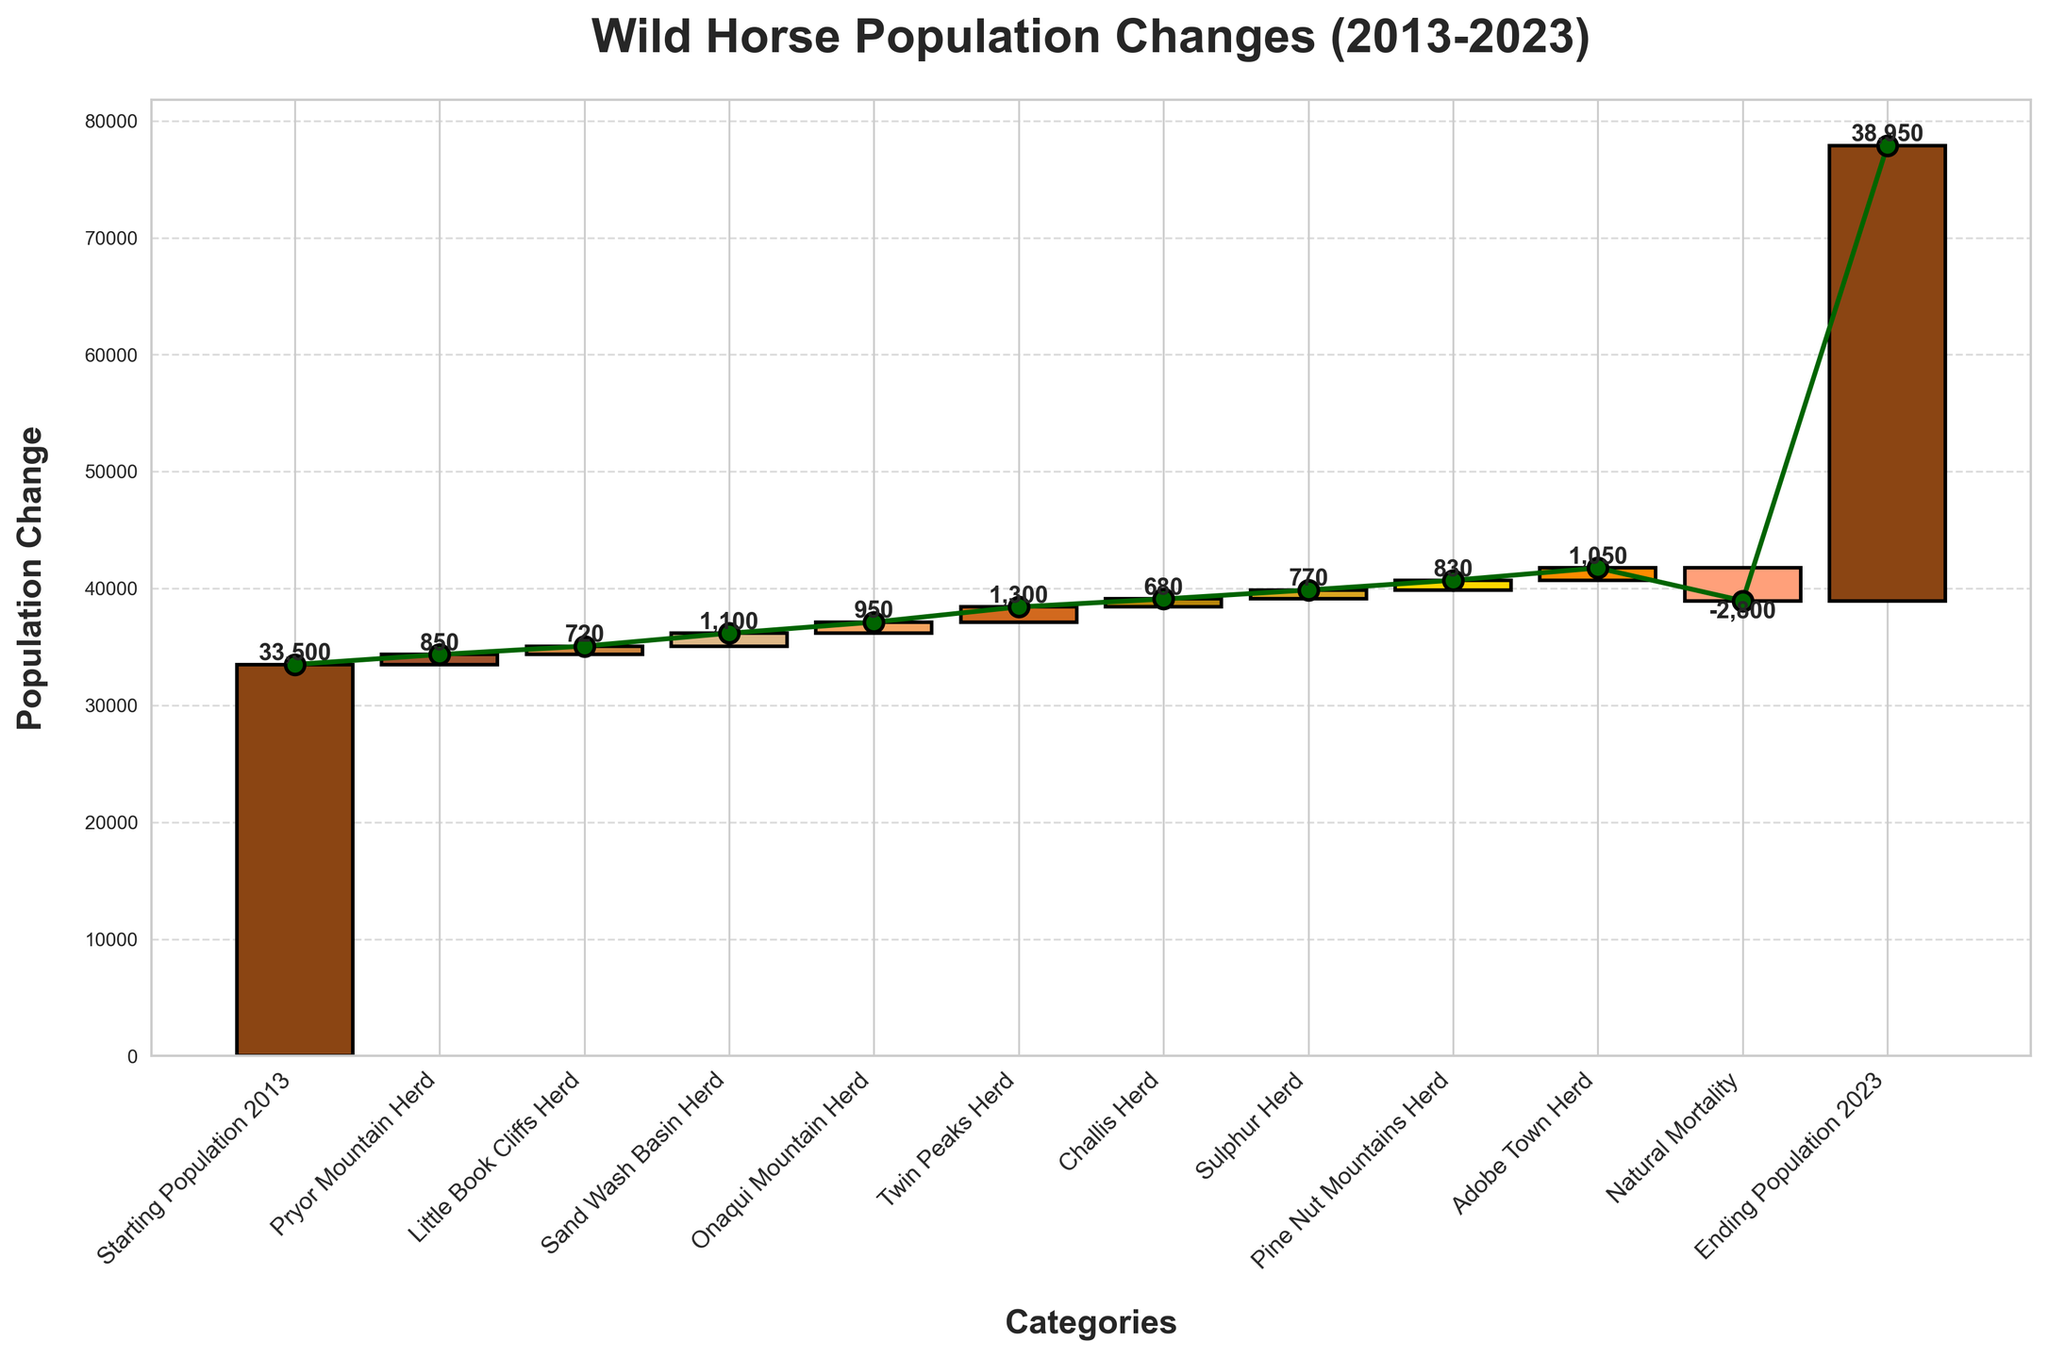What is the title of the figure? Look at the top of the chart where the title is usually located.
Answer: Wild Horse Population Changes (2013-2023) How many different herds contributed to the population change? By counting the names of the different herds in the categories list, excluding the starting and ending populations and natural mortality.
Answer: 8 What is the starting population of wild horses in 2013? Read the bar labeled "Starting Population 2013" at the beginning of the chart.
Answer: 33,500 Which herd contributed the most to the population increase? Compare the values of each herd addition and identify the highest one. Note "Twin Peaks Herd" has the largest value.
Answer: Twin Peaks Herd What is the net population change due to natural mortality? Check the bar labeled "Natural Mortality" for the value, usually indicated as a negative number on the vertical axis.
Answer: -2,800 What is the cumulative population after the contributions from Pryor Mountain and Little Book Cliffs herds? Sum the starting population with the values from Pryor Mountain and Little Book Cliffs herds: 33,500 + 850 + 720.
Answer: 35,070 Which herd's contribution exceeded 1,000 wild horses? Identify herds with values greater than 1,000 by examining the heights of the bar segments.
Answer: Sand Wash Basin Herd, Twin Peaks Herd, Adobe Town Herd What is the overall population change from 2013 to 2023? Calculate the difference between the ending population and the starting population: 38,950 - 33,500.
Answer: 5,450 How much did the Pine Nut Mountains Herd contribute to the population change? Check the bar labeled "Pine Nut Mountains Herd" for its value in the chart.
Answer: 830 Which herd contributions plus natural mortality results in a negative cumulative value? Sum the herd contributions and natural mortality up to see if the cumulative value falls below 33,500. The total sum including natural mortality and herds up to Sulphur Herd does not fall negative at any point.
Answer: None 